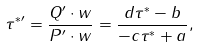Convert formula to latex. <formula><loc_0><loc_0><loc_500><loc_500>\tau ^ { * \prime } = \frac { Q ^ { \prime } \cdot w } { P ^ { \prime } \cdot w } = \frac { d \tau ^ { * } - b } { - c \tau ^ { * } + a } ,</formula> 